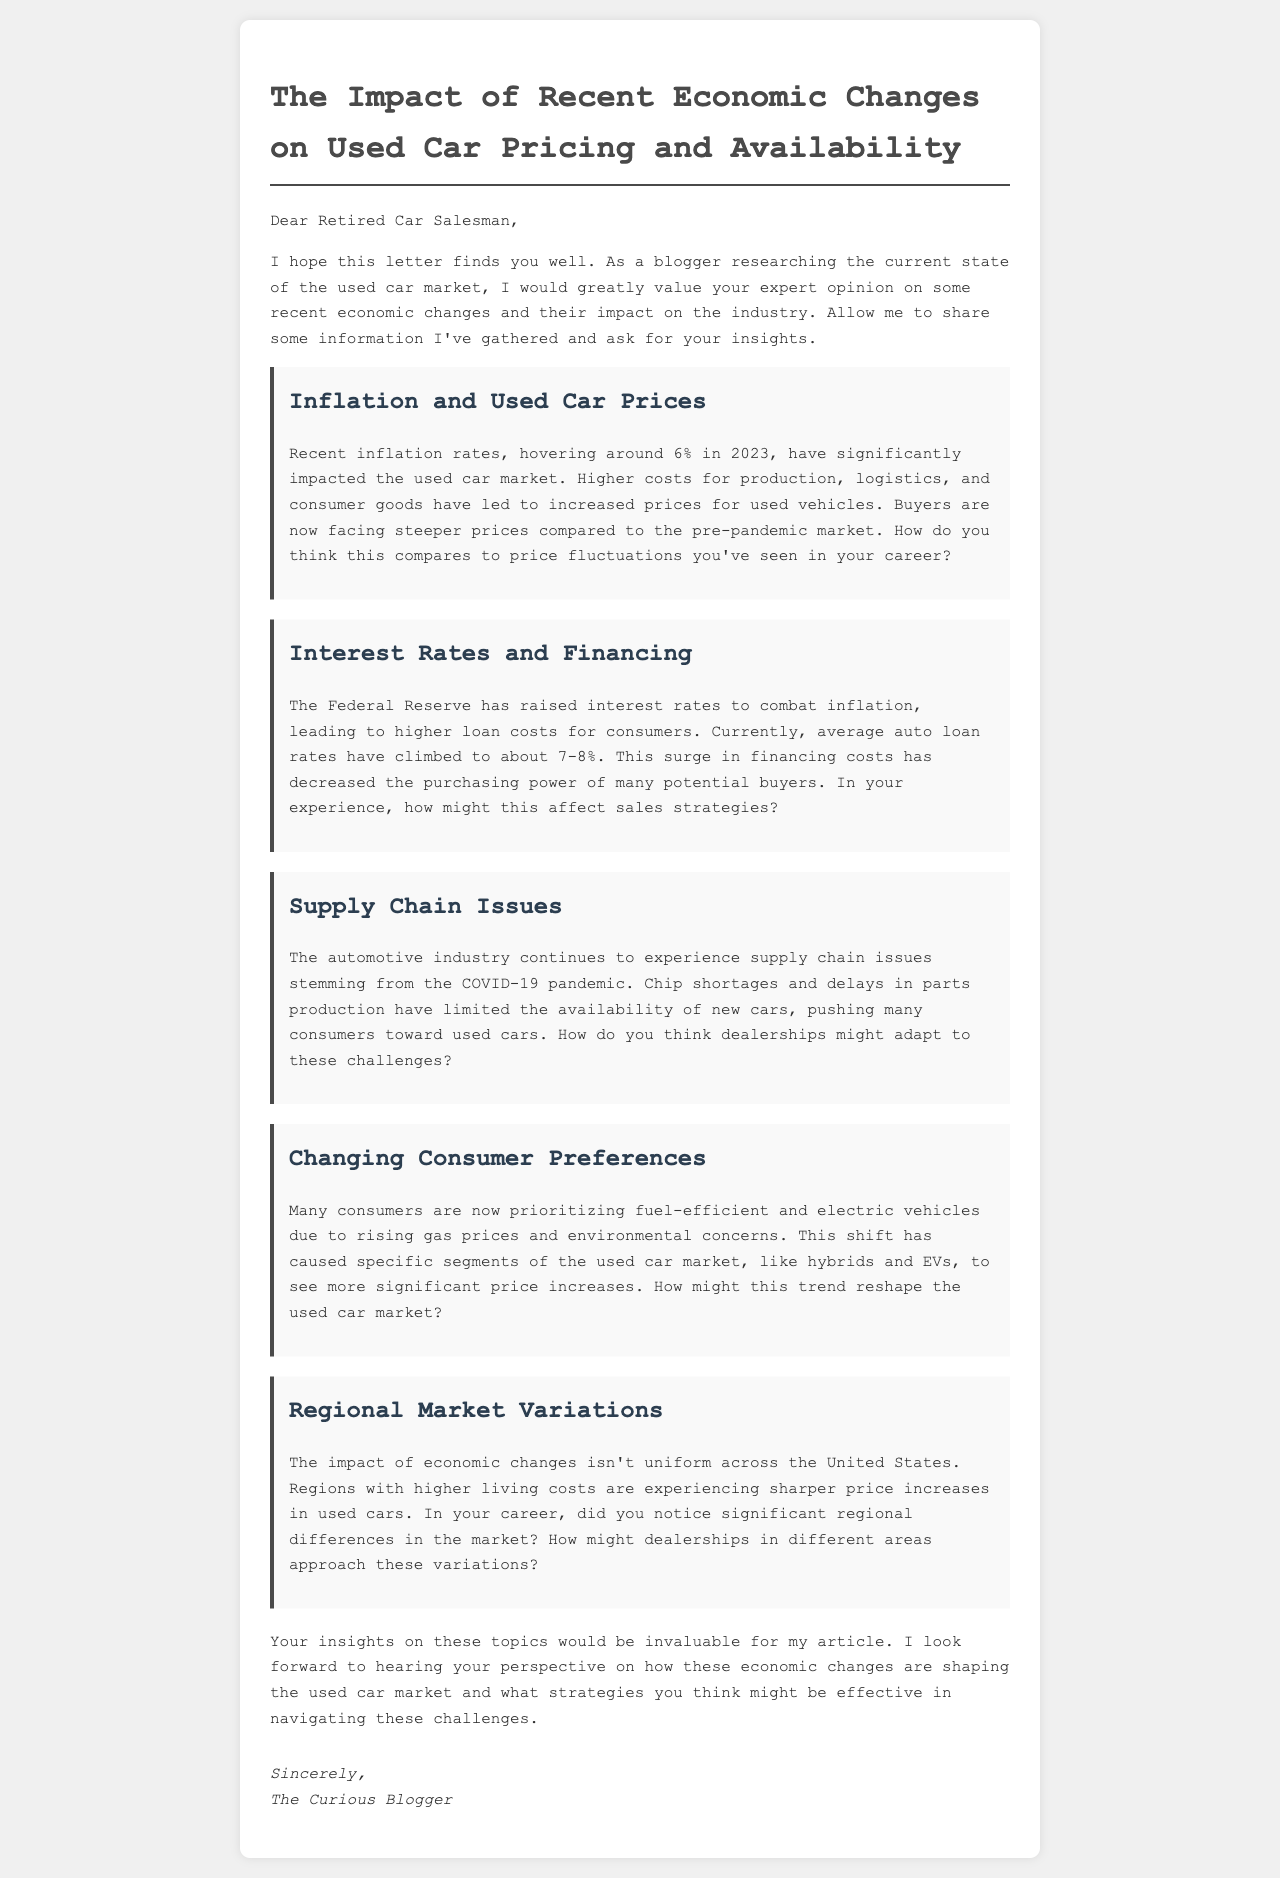What is the inflation rate mentioned in 2023? The document states that the inflation rate is hovering around 6% in 2023.
Answer: 6% What are the current average auto loan rates? The document indicates that average auto loan rates have climbed to about 7-8%.
Answer: 7-8% What significant issues does the automotive industry face due to the pandemic? The document mentions supply chain issues stemming from the COVID-19 pandemic, such as chip shortages and delays in parts production.
Answer: Supply chain issues What consumer preferences are influencing the used car market? The document notes that consumers are prioritizing fuel-efficient and electric vehicles due to rising gas prices and environmental concerns.
Answer: Fuel-efficient and electric vehicles How does the document describe regional market variations? The document states that regions with higher living costs are experiencing sharper price increases in used cars.
Answer: Higher living costs What is the purpose of the letter? The purpose of the letter is for the blogger to seek the retired car salesman's expert opinion on recent economic changes impacting the used car market.
Answer: Seek expert opinion What is the title of the letter? The title of the letter is "The Impact of Recent Economic Changes on Used Car Pricing and Availability."
Answer: The Impact of Recent Economic Changes on Used Car Pricing and Availability Which specific vehicle segments have seen more significant price increases? The document mentions that hybrids and EVs have seen more significant price increases.
Answer: Hybrids and EVs 